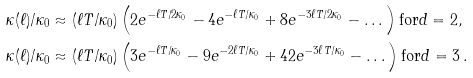Convert formula to latex. <formula><loc_0><loc_0><loc_500><loc_500>& { \kappa ( \ell ) } / { \kappa _ { 0 } } \approx ( { \ell T } / { \kappa _ { 0 } } ) \left ( 2 e ^ { - \ell T / 2 \kappa _ { 0 } } - 4 e ^ { - \ell T / \kappa _ { 0 } } + 8 e ^ { - 3 \ell T / 2 \kappa _ { 0 } } - \dots \right ) \text {for} d = 2 , \\ & { \kappa ( \ell ) } / { \kappa _ { 0 } } \approx ( { \ell T } / { \kappa _ { 0 } } ) \left ( 3 e ^ { - \ell T / \kappa _ { 0 } } - 9 e ^ { - 2 \ell T / \kappa _ { 0 } } + 4 2 e ^ { - 3 \ell T / \kappa _ { 0 } } - \dots \right ) \text {for} d = 3 \, .</formula> 